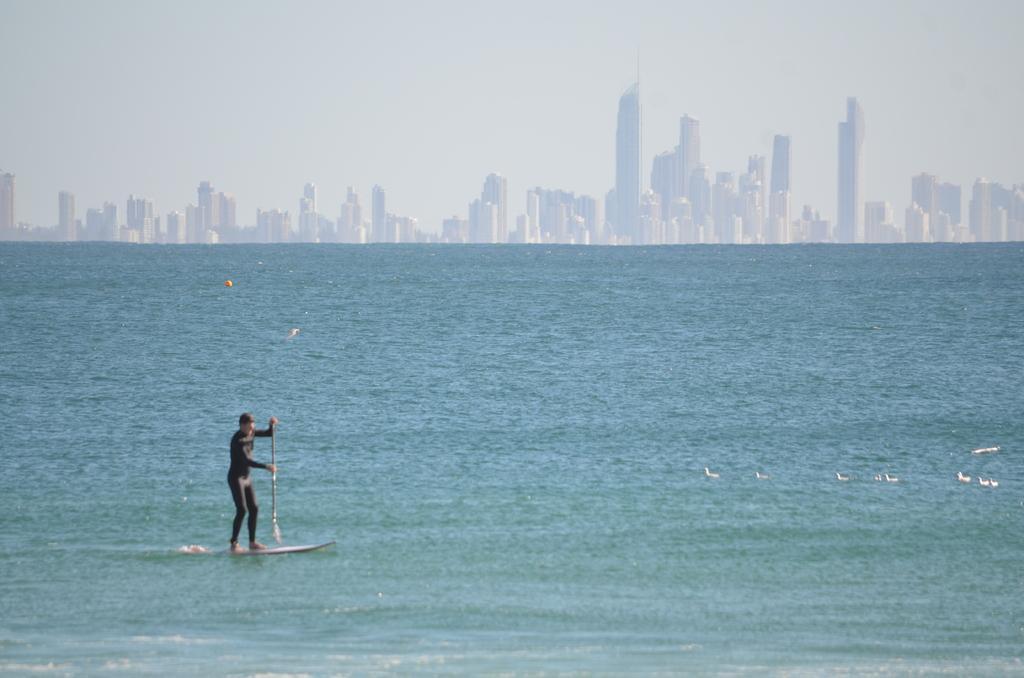Could you give a brief overview of what you see in this image? In this image we can see a person surfacing on the water. On the right side, we can see few birds on the water. Behind the water we can see a group of buildings. At the top we can see the sky. 